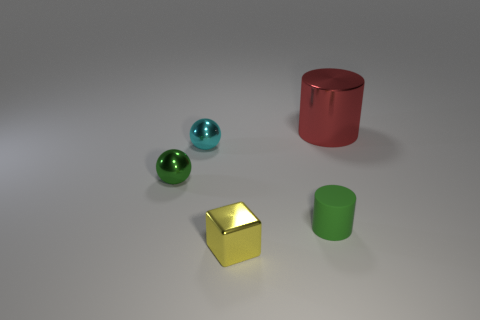The tiny green object that is right of the metal thing in front of the cylinder that is on the left side of the large red metal object is what shape?
Make the answer very short. Cylinder. Are there any cyan metallic balls that have the same size as the yellow cube?
Make the answer very short. Yes. What size is the yellow shiny thing?
Give a very brief answer. Small. What number of metallic cylinders are the same size as the shiny block?
Offer a terse response. 0. Is the number of tiny metal objects behind the green shiny object less than the number of green metallic spheres in front of the tiny green cylinder?
Keep it short and to the point. No. There is a thing that is in front of the cylinder to the left of the cylinder on the right side of the small rubber cylinder; how big is it?
Keep it short and to the point. Small. There is a object that is both behind the small green sphere and left of the tiny cylinder; what size is it?
Keep it short and to the point. Small. What is the shape of the metallic object on the right side of the thing that is in front of the tiny matte object?
Your response must be concise. Cylinder. Is there any other thing of the same color as the metal cylinder?
Provide a short and direct response. No. What is the shape of the tiny green thing that is on the right side of the green shiny ball?
Offer a very short reply. Cylinder. 